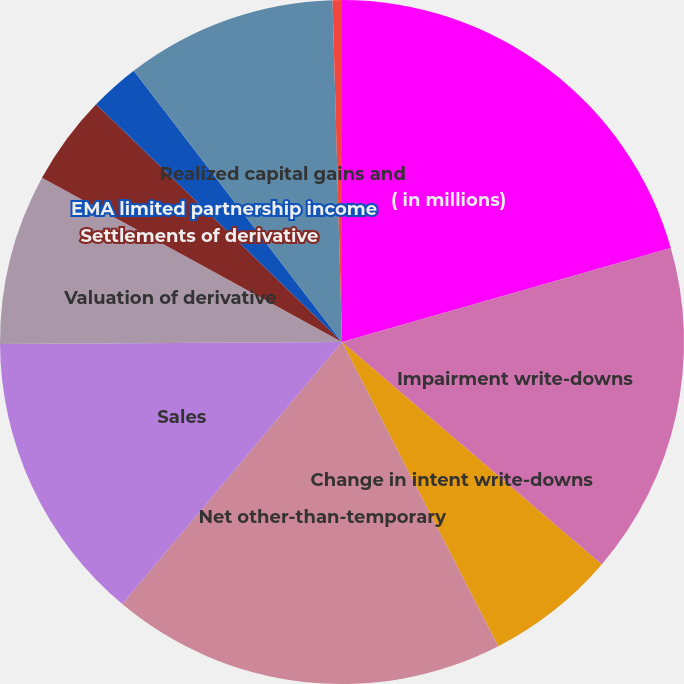Convert chart to OTSL. <chart><loc_0><loc_0><loc_500><loc_500><pie_chart><fcel>( in millions)<fcel>Impairment write-downs<fcel>Change in intent write-downs<fcel>Net other-than-temporary<fcel>Sales<fcel>Valuation of derivative<fcel>Settlements of derivative<fcel>EMA limited partnership income<fcel>Realized capital gains and<fcel>Income tax benefit (expense)<nl><fcel>20.57%<fcel>15.71%<fcel>6.17%<fcel>18.66%<fcel>13.8%<fcel>8.07%<fcel>4.26%<fcel>2.35%<fcel>9.98%<fcel>0.44%<nl></chart> 